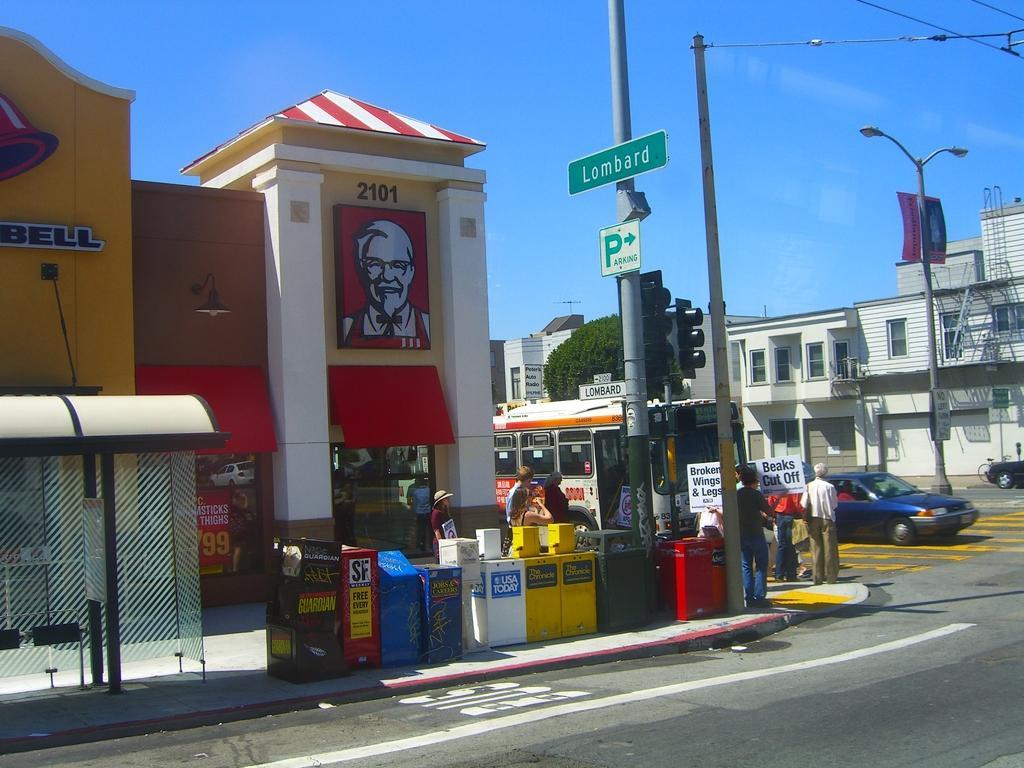How would you summarize this image in a sentence or two? In the center of the image we can see a few boxes with posters. In the background, we can see the sky, buildings, poles, vehicles, few peoples and a few other objects. 